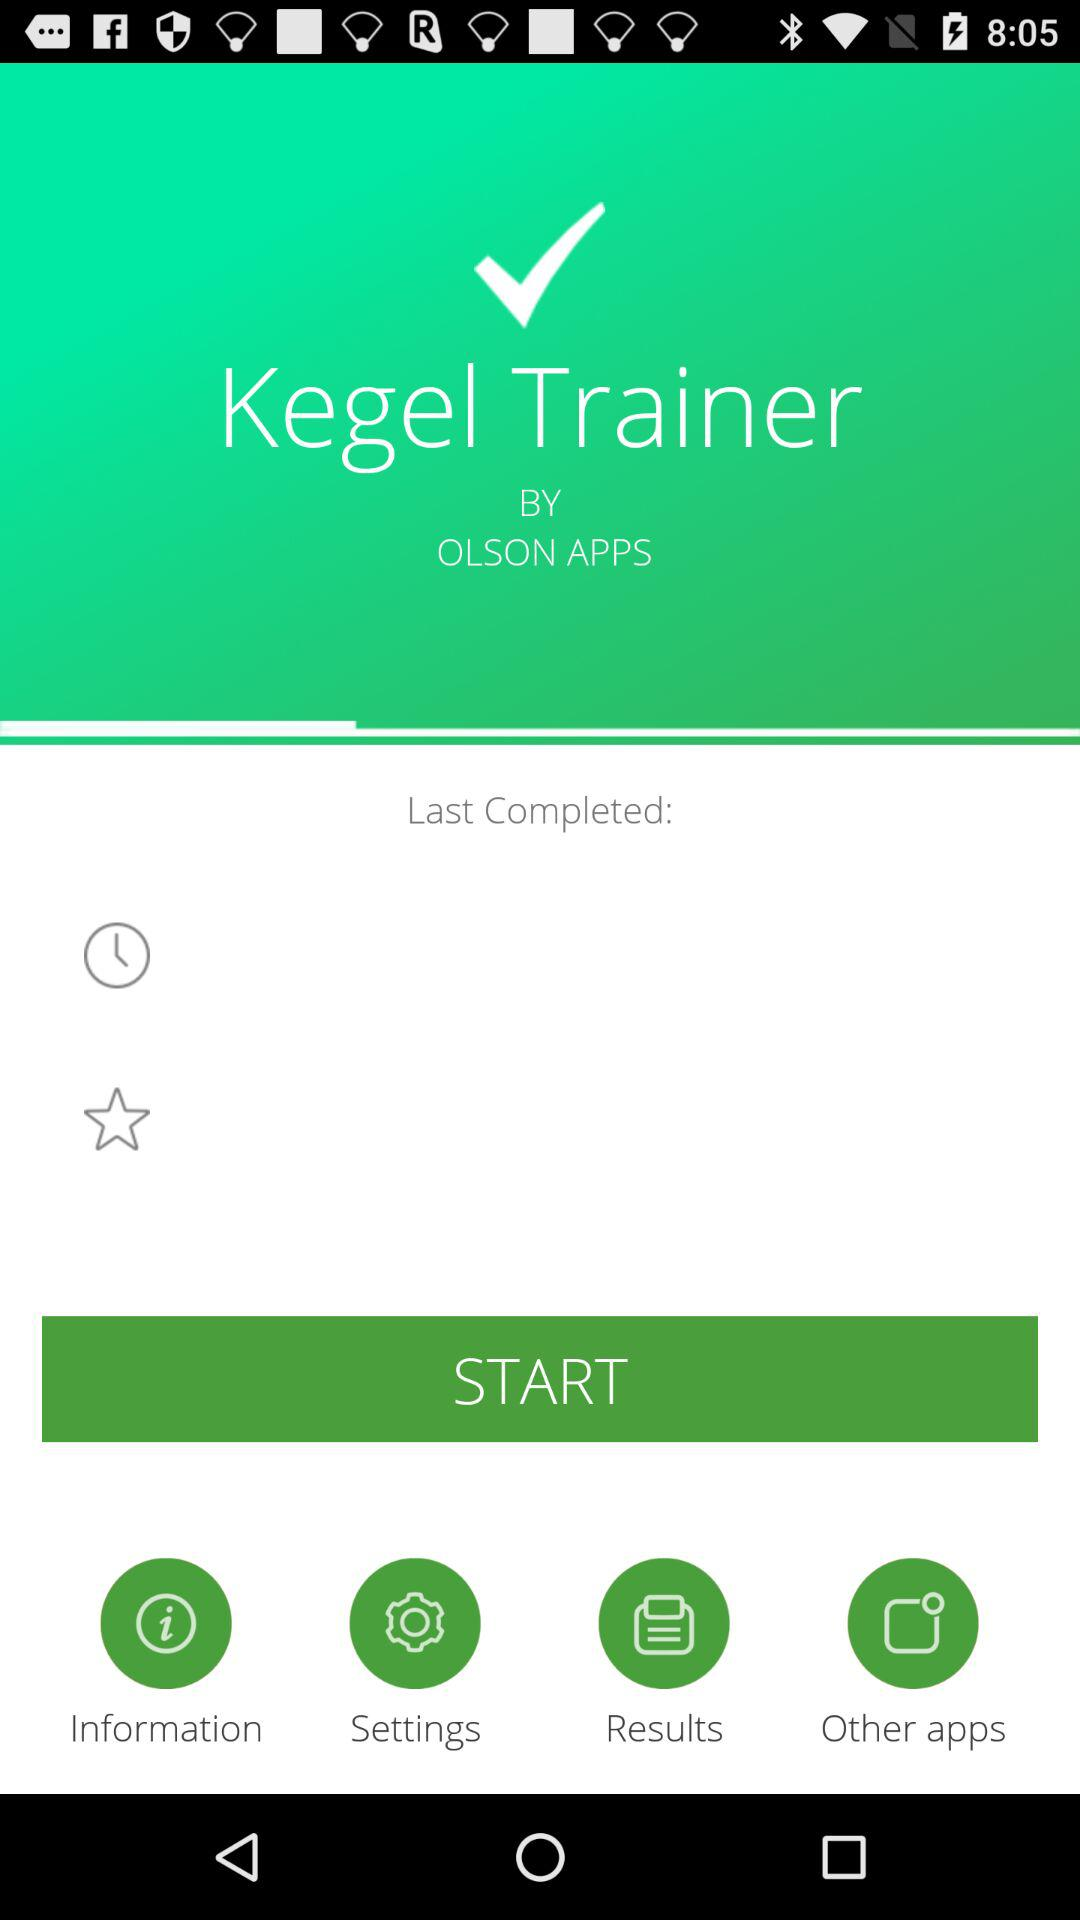What is the name of the application? The name of the application is "Kegel Trainer". 